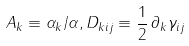<formula> <loc_0><loc_0><loc_500><loc_500>A _ { k } \equiv \alpha _ { k } / \alpha , D _ { k i j } \equiv \frac { 1 } { 2 } \, \partial _ { k } \gamma _ { i j }</formula> 